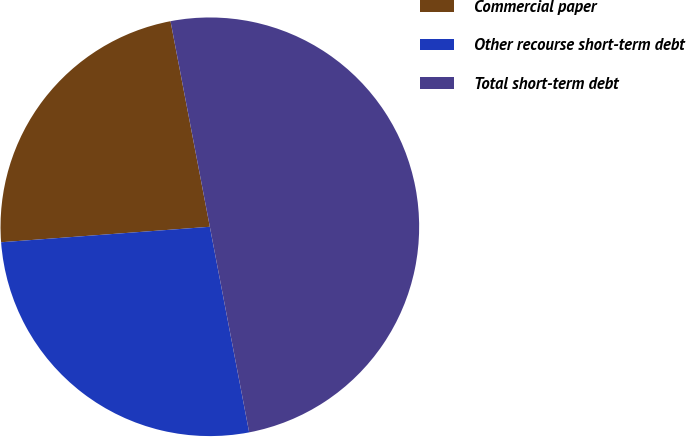Convert chart to OTSL. <chart><loc_0><loc_0><loc_500><loc_500><pie_chart><fcel>Commercial paper<fcel>Other recourse short-term debt<fcel>Total short-term debt<nl><fcel>23.17%<fcel>26.83%<fcel>50.0%<nl></chart> 